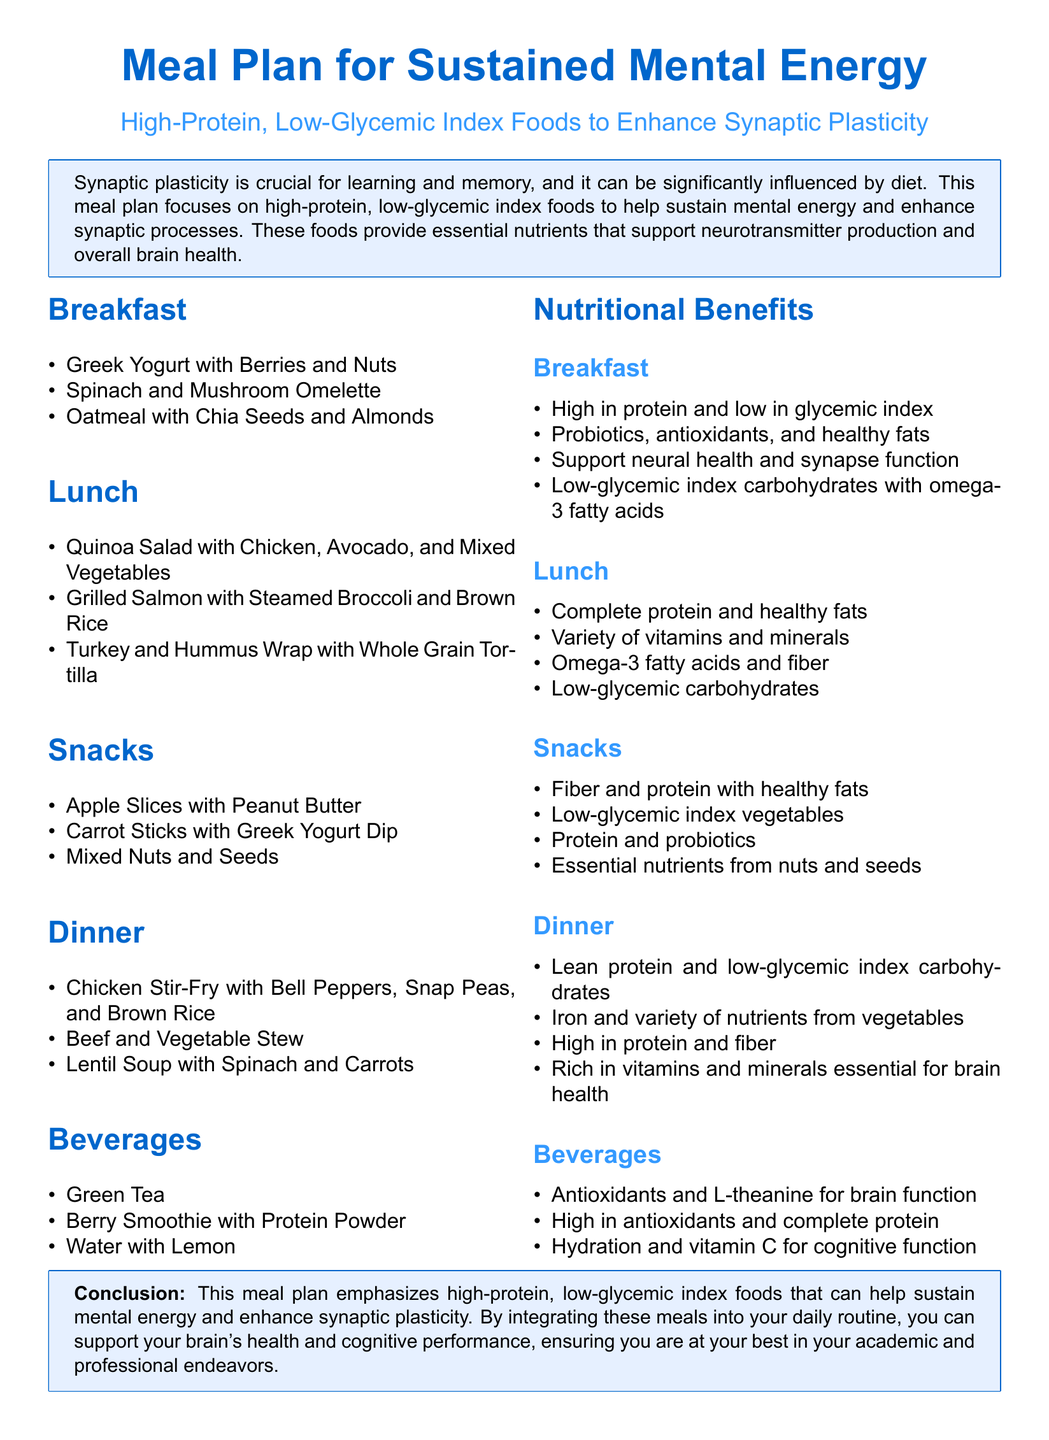What are the recommended breakfast items? The breakfast items listed in the document are Greek Yogurt with Berries and Nuts, Spinach and Mushroom Omelette, and Oatmeal with Chia Seeds and Almonds.
Answer: Greek Yogurt with Berries and Nuts, Spinach and Mushroom Omelette, Oatmeal with Chia Seeds and Almonds What type of tea is suggested in the beverage section? The beverage section mentions Green Tea as one of the suggested drinks.
Answer: Green Tea What is the main focus of the meal plan? The main focus of the meal plan is on high-protein, low-glycemic index foods to help sustain mental energy and enhance synaptic processes.
Answer: High-protein, low-glycemic index foods What are the key components in the lunch section? The lunch section highlights complete protein, healthy fats, and a variety of vitamins and minerals as key components.
Answer: Complete protein and healthy fats How many snacks are included in the meal plan? The document provides a list of three snacks included in the meal plan.
Answer: Three What nutrient is emphasized for breakfast foods? The breakfast foods are emphasized for being high in protein and low in glycemic index.
Answer: High in protein and low in glycemic index Which food is listed as a dinner option that includes vegetables? The Beef and Vegetable Stew is one of the dinner options that includes vegetables.
Answer: Beef and Vegetable Stew What kind of protein source is mentioned in the breakfast section? Greek Yogurt is mentioned as a protein source in the breakfast section.
Answer: Greek Yogurt 